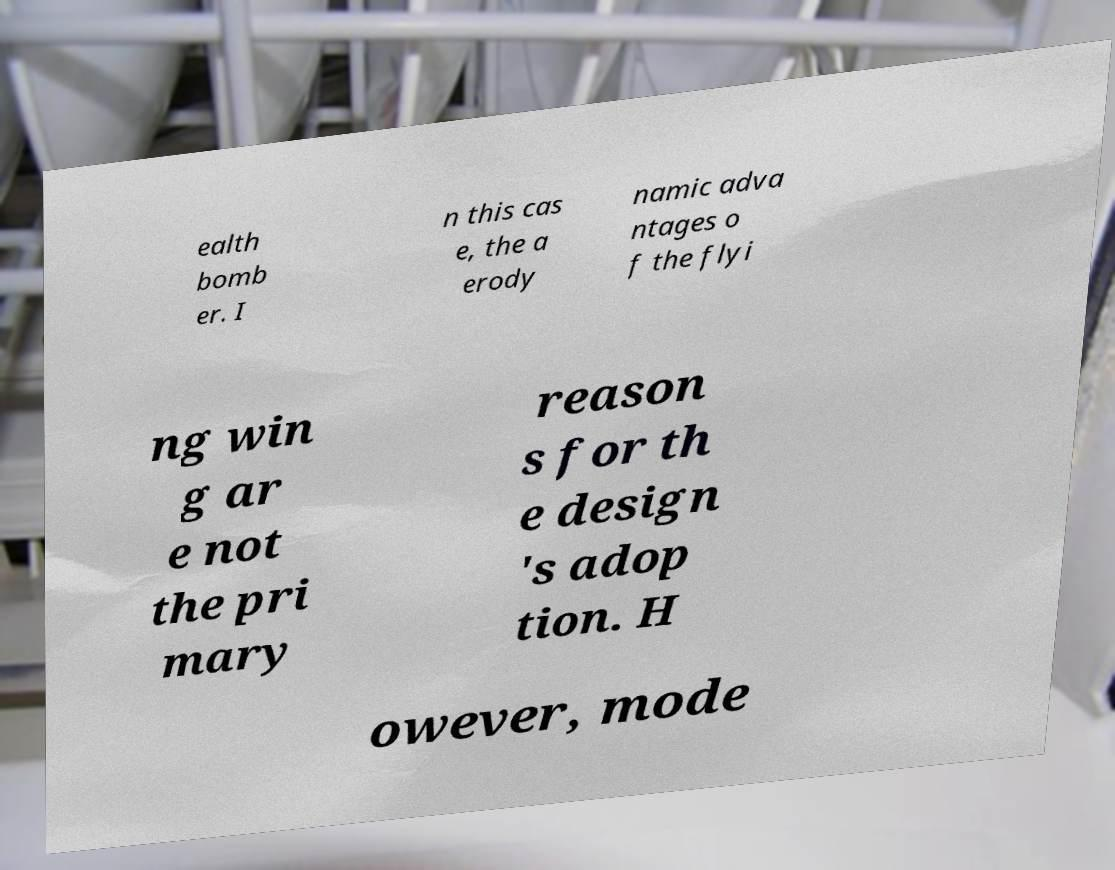Can you read and provide the text displayed in the image?This photo seems to have some interesting text. Can you extract and type it out for me? ealth bomb er. I n this cas e, the a erody namic adva ntages o f the flyi ng win g ar e not the pri mary reason s for th e design 's adop tion. H owever, mode 